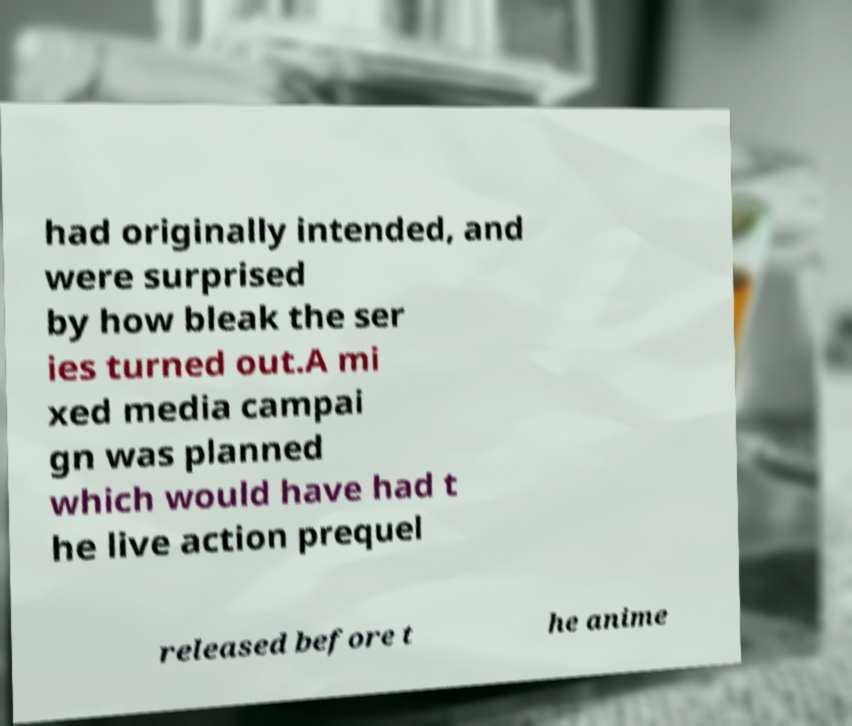For documentation purposes, I need the text within this image transcribed. Could you provide that? had originally intended, and were surprised by how bleak the ser ies turned out.A mi xed media campai gn was planned which would have had t he live action prequel released before t he anime 